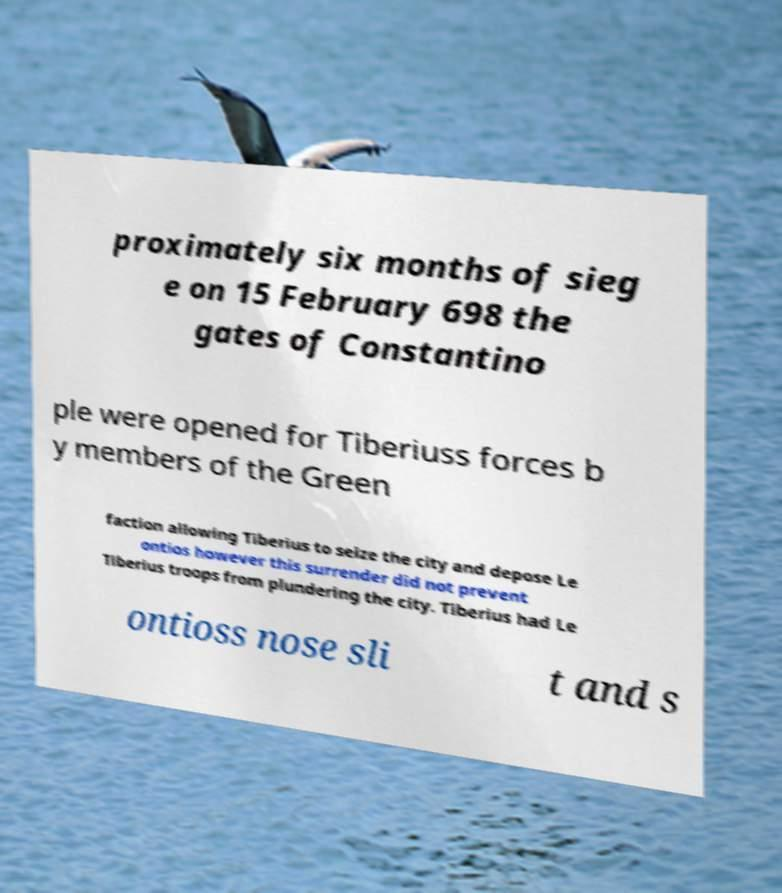What messages or text are displayed in this image? I need them in a readable, typed format. proximately six months of sieg e on 15 February 698 the gates of Constantino ple were opened for Tiberiuss forces b y members of the Green faction allowing Tiberius to seize the city and depose Le ontios however this surrender did not prevent Tiberius troops from plundering the city. Tiberius had Le ontioss nose sli t and s 